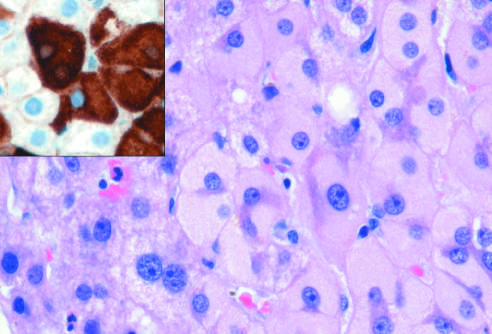what does immunostaining with a specific antibody confirm?
Answer the question using a single word or phrase. The presence of surface antigen 